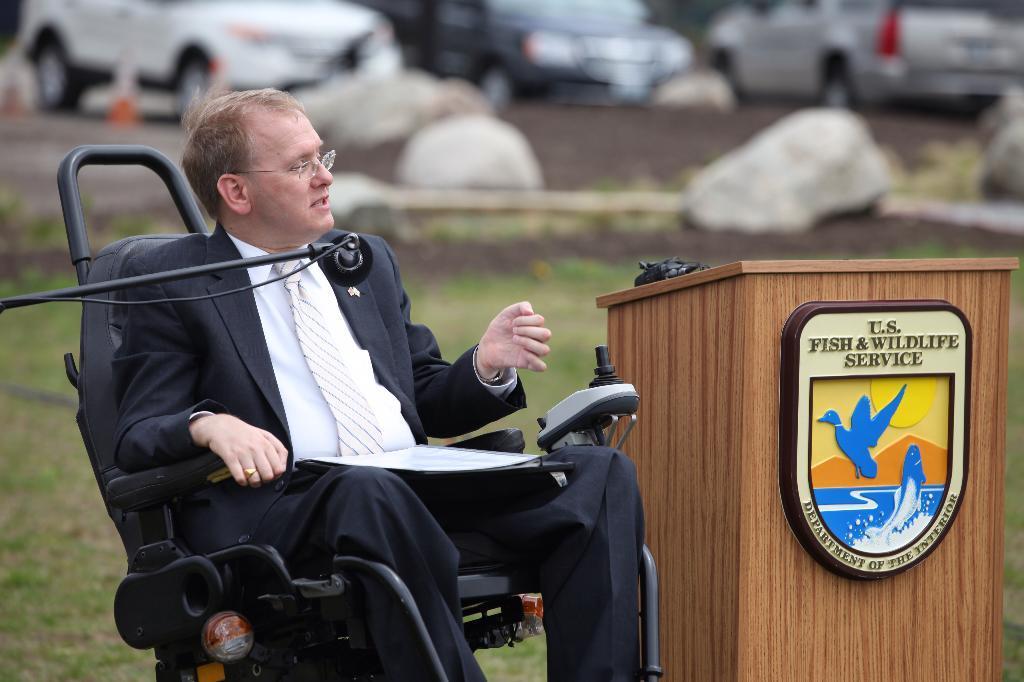How would you summarize this image in a sentence or two? In this image we can see a person wearing blazer is sitting on the wheelchair. There is a mic in front of him and podium beside him. In the background we can see many cars. 